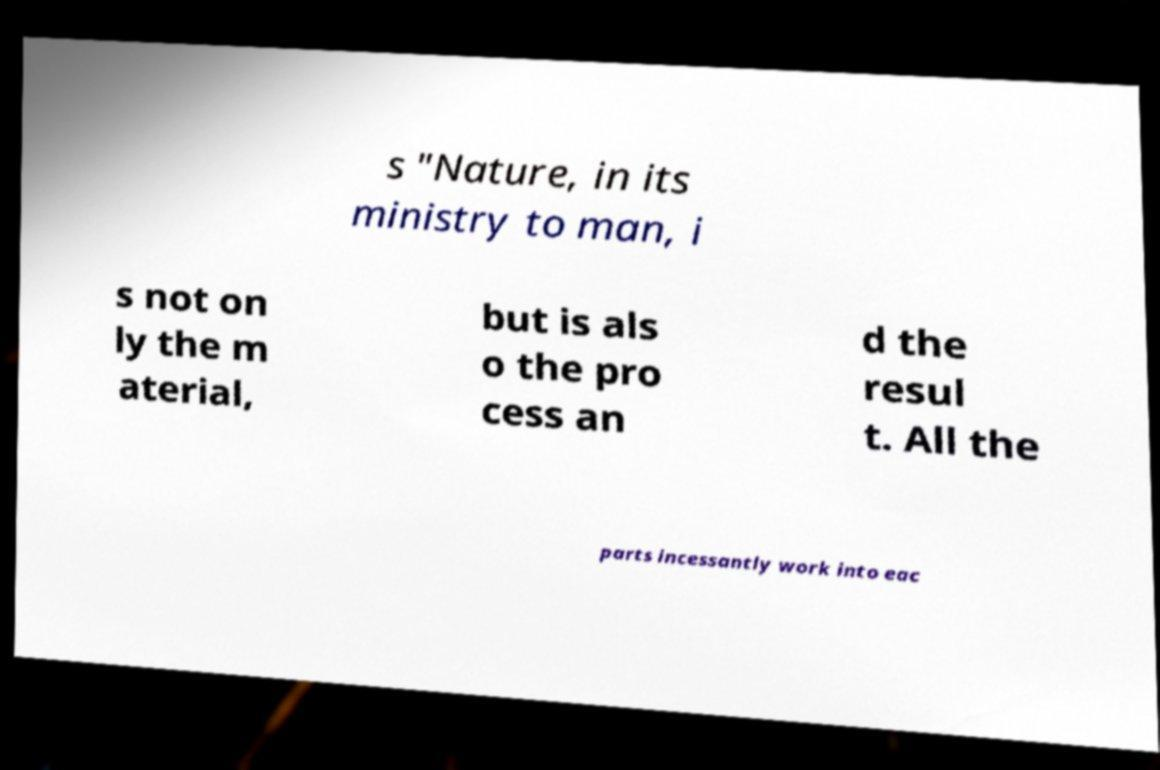Can you accurately transcribe the text from the provided image for me? s "Nature, in its ministry to man, i s not on ly the m aterial, but is als o the pro cess an d the resul t. All the parts incessantly work into eac 